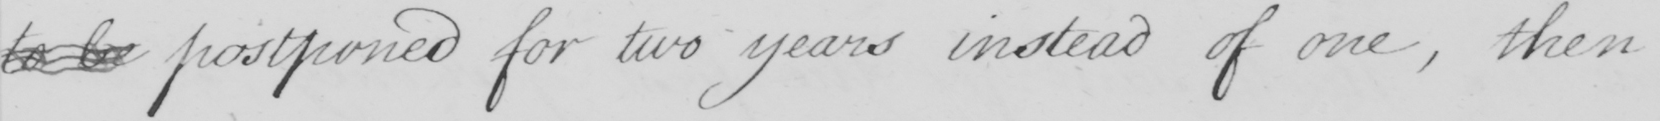Please provide the text content of this handwritten line. to be postponed for two years instead of one , then 